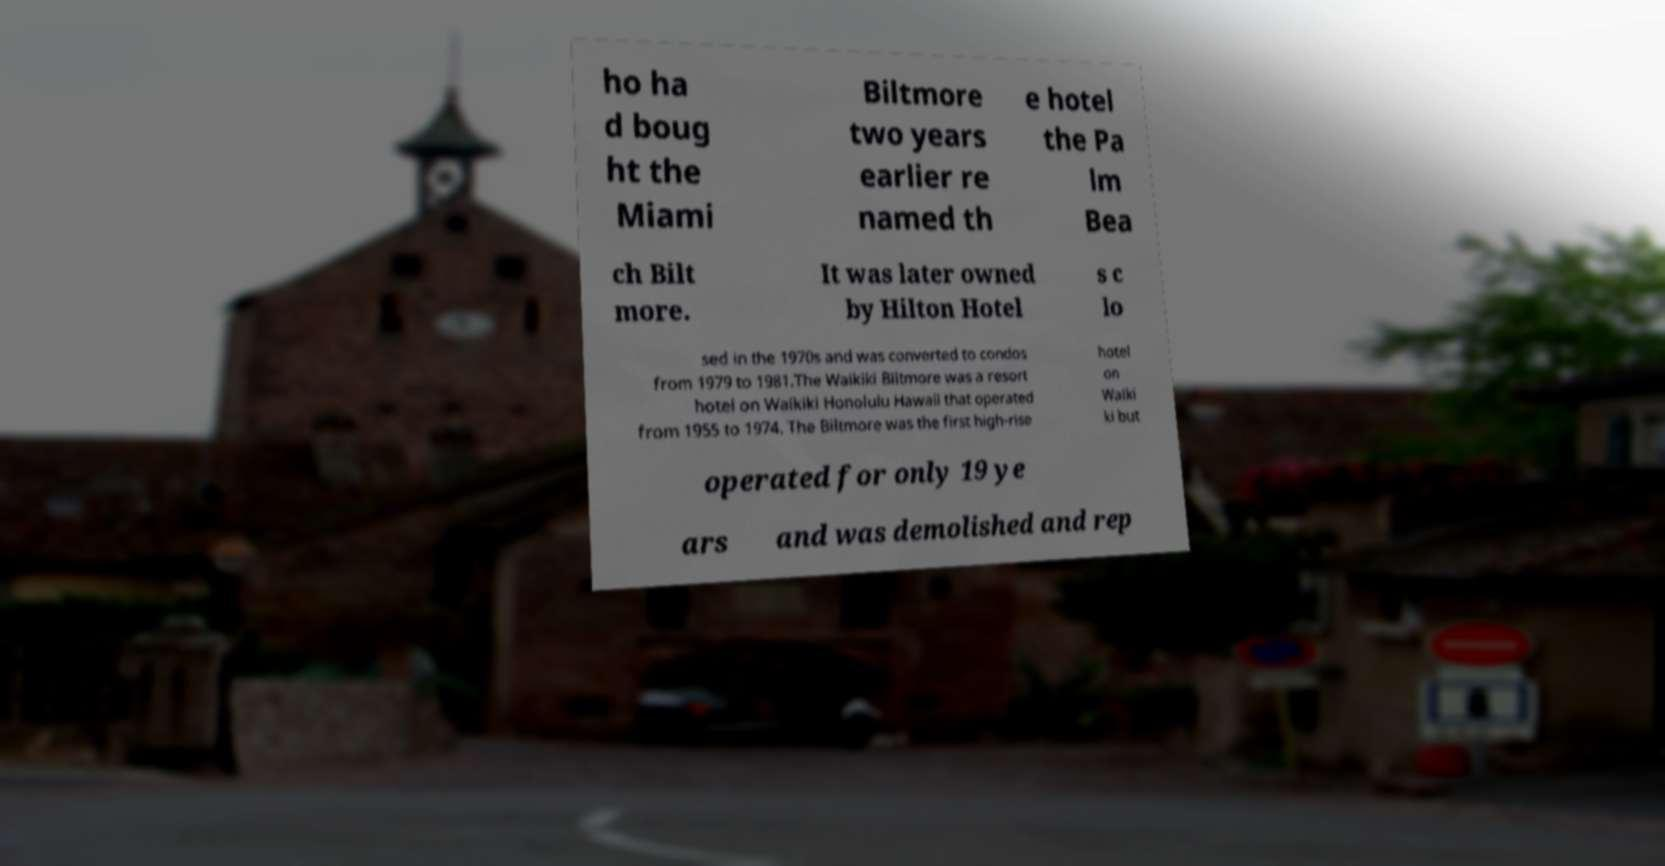Can you read and provide the text displayed in the image?This photo seems to have some interesting text. Can you extract and type it out for me? ho ha d boug ht the Miami Biltmore two years earlier re named th e hotel the Pa lm Bea ch Bilt more. It was later owned by Hilton Hotel s c lo sed in the 1970s and was converted to condos from 1979 to 1981.The Waikiki Biltmore was a resort hotel on Waikiki Honolulu Hawaii that operated from 1955 to 1974. The Biltmore was the first high-rise hotel on Waiki ki but operated for only 19 ye ars and was demolished and rep 